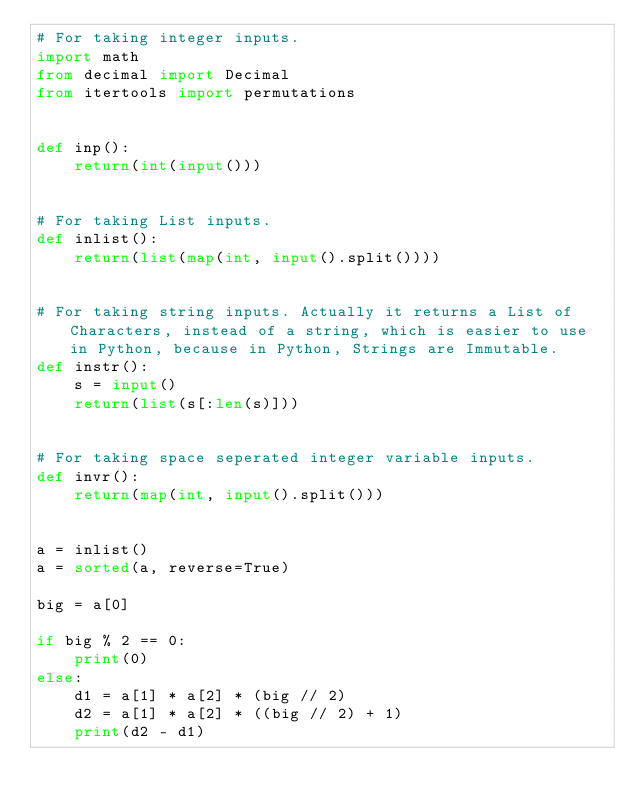Convert code to text. <code><loc_0><loc_0><loc_500><loc_500><_Python_># For taking integer inputs.
import math
from decimal import Decimal
from itertools import permutations


def inp():
    return(int(input()))


# For taking List inputs.
def inlist():
    return(list(map(int, input().split())))


# For taking string inputs. Actually it returns a List of Characters, instead of a string, which is easier to use in Python, because in Python, Strings are Immutable.
def instr():
    s = input()
    return(list(s[:len(s)]))


# For taking space seperated integer variable inputs.
def invr():
    return(map(int, input().split()))


a = inlist()
a = sorted(a, reverse=True)

big = a[0]

if big % 2 == 0:
    print(0)
else:
    d1 = a[1] * a[2] * (big // 2)
    d2 = a[1] * a[2] * ((big // 2) + 1)
    print(d2 - d1)
</code> 